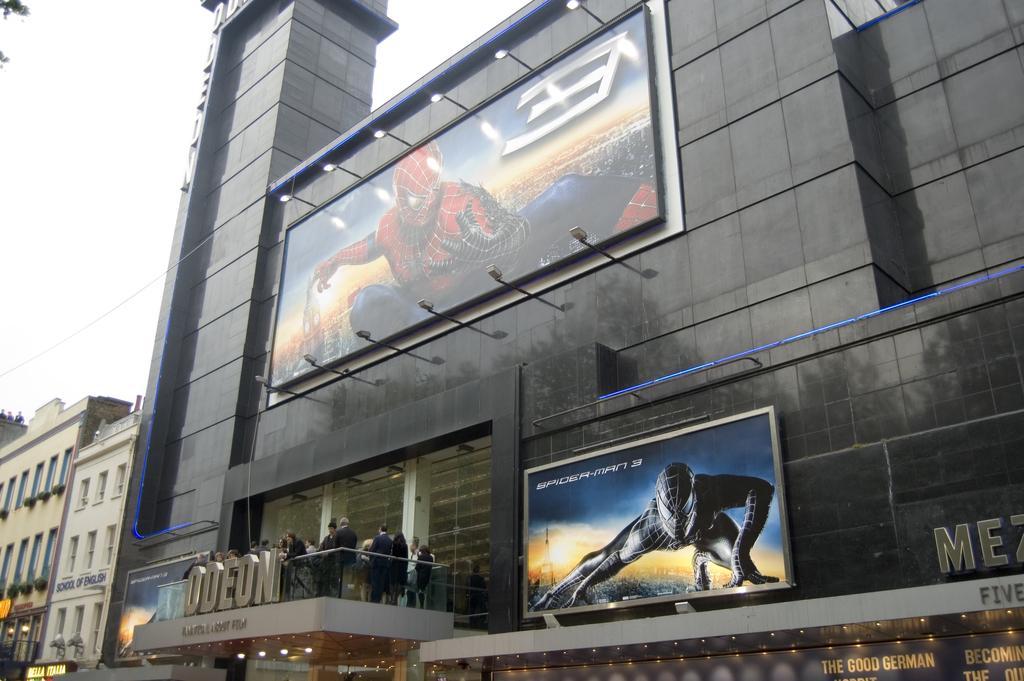Please provide a concise description of this image. In this image we can see there are buildings and persons standing in it. And there is a board with an image. And at the top there is a sky. 